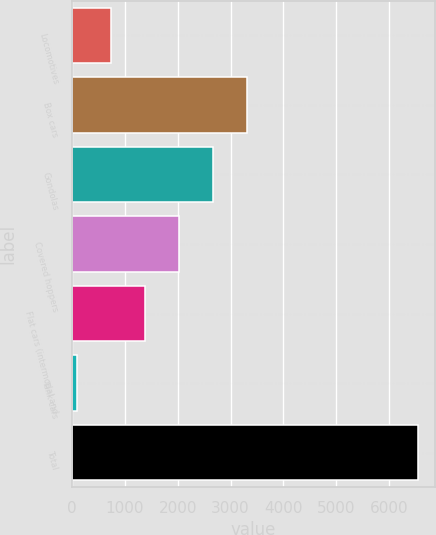Convert chart to OTSL. <chart><loc_0><loc_0><loc_500><loc_500><bar_chart><fcel>Locomotives<fcel>Box cars<fcel>Gondolas<fcel>Covered hoppers<fcel>Flat cars (intermodal and<fcel>Tank cars<fcel>Total<nl><fcel>738.8<fcel>3322<fcel>2676.2<fcel>2030.4<fcel>1384.6<fcel>93<fcel>6551<nl></chart> 